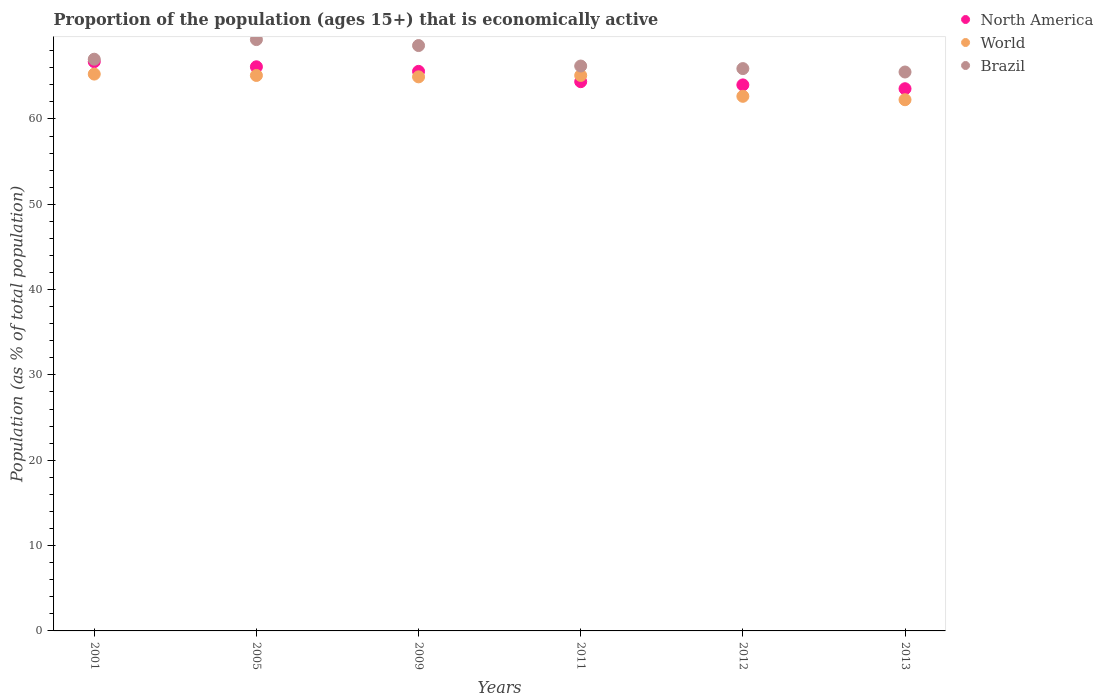How many different coloured dotlines are there?
Your response must be concise. 3. Is the number of dotlines equal to the number of legend labels?
Make the answer very short. Yes. What is the proportion of the population that is economically active in World in 2011?
Offer a very short reply. 65.1. Across all years, what is the maximum proportion of the population that is economically active in North America?
Provide a short and direct response. 66.71. Across all years, what is the minimum proportion of the population that is economically active in North America?
Offer a terse response. 63.54. In which year was the proportion of the population that is economically active in North America maximum?
Offer a terse response. 2001. In which year was the proportion of the population that is economically active in North America minimum?
Your answer should be compact. 2013. What is the total proportion of the population that is economically active in Brazil in the graph?
Keep it short and to the point. 402.5. What is the difference between the proportion of the population that is economically active in Brazil in 2009 and that in 2011?
Provide a short and direct response. 2.4. What is the difference between the proportion of the population that is economically active in Brazil in 2001 and the proportion of the population that is economically active in World in 2009?
Provide a short and direct response. 2.07. What is the average proportion of the population that is economically active in Brazil per year?
Ensure brevity in your answer.  67.08. In the year 2005, what is the difference between the proportion of the population that is economically active in North America and proportion of the population that is economically active in World?
Offer a terse response. 1.02. What is the ratio of the proportion of the population that is economically active in North America in 2009 to that in 2012?
Keep it short and to the point. 1.02. Is the difference between the proportion of the population that is economically active in North America in 2005 and 2012 greater than the difference between the proportion of the population that is economically active in World in 2005 and 2012?
Provide a short and direct response. No. What is the difference between the highest and the second highest proportion of the population that is economically active in North America?
Your answer should be compact. 0.6. What is the difference between the highest and the lowest proportion of the population that is economically active in Brazil?
Your response must be concise. 3.8. In how many years, is the proportion of the population that is economically active in Brazil greater than the average proportion of the population that is economically active in Brazil taken over all years?
Your response must be concise. 2. Is the sum of the proportion of the population that is economically active in Brazil in 2005 and 2009 greater than the maximum proportion of the population that is economically active in North America across all years?
Offer a very short reply. Yes. How many years are there in the graph?
Your answer should be compact. 6. Are the values on the major ticks of Y-axis written in scientific E-notation?
Provide a short and direct response. No. Does the graph contain any zero values?
Give a very brief answer. No. Where does the legend appear in the graph?
Offer a terse response. Top right. How many legend labels are there?
Your answer should be compact. 3. What is the title of the graph?
Your answer should be very brief. Proportion of the population (ages 15+) that is economically active. Does "High income: nonOECD" appear as one of the legend labels in the graph?
Your response must be concise. No. What is the label or title of the Y-axis?
Provide a succinct answer. Population (as % of total population). What is the Population (as % of total population) in North America in 2001?
Ensure brevity in your answer.  66.71. What is the Population (as % of total population) of World in 2001?
Make the answer very short. 65.26. What is the Population (as % of total population) in Brazil in 2001?
Your answer should be compact. 67. What is the Population (as % of total population) in North America in 2005?
Offer a very short reply. 66.11. What is the Population (as % of total population) of World in 2005?
Give a very brief answer. 65.1. What is the Population (as % of total population) in Brazil in 2005?
Make the answer very short. 69.3. What is the Population (as % of total population) of North America in 2009?
Your response must be concise. 65.57. What is the Population (as % of total population) of World in 2009?
Ensure brevity in your answer.  64.93. What is the Population (as % of total population) in Brazil in 2009?
Offer a terse response. 68.6. What is the Population (as % of total population) in North America in 2011?
Provide a short and direct response. 64.37. What is the Population (as % of total population) of World in 2011?
Offer a terse response. 65.1. What is the Population (as % of total population) of Brazil in 2011?
Give a very brief answer. 66.2. What is the Population (as % of total population) in North America in 2012?
Your response must be concise. 63.99. What is the Population (as % of total population) of World in 2012?
Offer a terse response. 62.65. What is the Population (as % of total population) in Brazil in 2012?
Offer a terse response. 65.9. What is the Population (as % of total population) in North America in 2013?
Ensure brevity in your answer.  63.54. What is the Population (as % of total population) of World in 2013?
Give a very brief answer. 62.25. What is the Population (as % of total population) of Brazil in 2013?
Make the answer very short. 65.5. Across all years, what is the maximum Population (as % of total population) of North America?
Your answer should be compact. 66.71. Across all years, what is the maximum Population (as % of total population) of World?
Ensure brevity in your answer.  65.26. Across all years, what is the maximum Population (as % of total population) of Brazil?
Provide a succinct answer. 69.3. Across all years, what is the minimum Population (as % of total population) of North America?
Offer a very short reply. 63.54. Across all years, what is the minimum Population (as % of total population) of World?
Offer a terse response. 62.25. Across all years, what is the minimum Population (as % of total population) in Brazil?
Offer a terse response. 65.5. What is the total Population (as % of total population) of North America in the graph?
Provide a succinct answer. 390.29. What is the total Population (as % of total population) in World in the graph?
Ensure brevity in your answer.  385.28. What is the total Population (as % of total population) in Brazil in the graph?
Offer a very short reply. 402.5. What is the difference between the Population (as % of total population) of North America in 2001 and that in 2005?
Your answer should be very brief. 0.6. What is the difference between the Population (as % of total population) in World in 2001 and that in 2005?
Your answer should be very brief. 0.16. What is the difference between the Population (as % of total population) of North America in 2001 and that in 2009?
Your response must be concise. 1.14. What is the difference between the Population (as % of total population) of World in 2001 and that in 2009?
Keep it short and to the point. 0.32. What is the difference between the Population (as % of total population) in Brazil in 2001 and that in 2009?
Your answer should be very brief. -1.6. What is the difference between the Population (as % of total population) in North America in 2001 and that in 2011?
Offer a very short reply. 2.34. What is the difference between the Population (as % of total population) in World in 2001 and that in 2011?
Give a very brief answer. 0.16. What is the difference between the Population (as % of total population) in Brazil in 2001 and that in 2011?
Make the answer very short. 0.8. What is the difference between the Population (as % of total population) in North America in 2001 and that in 2012?
Provide a short and direct response. 2.72. What is the difference between the Population (as % of total population) of World in 2001 and that in 2012?
Provide a succinct answer. 2.6. What is the difference between the Population (as % of total population) in Brazil in 2001 and that in 2012?
Make the answer very short. 1.1. What is the difference between the Population (as % of total population) of North America in 2001 and that in 2013?
Keep it short and to the point. 3.17. What is the difference between the Population (as % of total population) of World in 2001 and that in 2013?
Give a very brief answer. 3. What is the difference between the Population (as % of total population) in North America in 2005 and that in 2009?
Ensure brevity in your answer.  0.54. What is the difference between the Population (as % of total population) of World in 2005 and that in 2009?
Make the answer very short. 0.16. What is the difference between the Population (as % of total population) in Brazil in 2005 and that in 2009?
Your response must be concise. 0.7. What is the difference between the Population (as % of total population) of North America in 2005 and that in 2011?
Your answer should be very brief. 1.74. What is the difference between the Population (as % of total population) of World in 2005 and that in 2011?
Your answer should be very brief. -0. What is the difference between the Population (as % of total population) in North America in 2005 and that in 2012?
Offer a terse response. 2.12. What is the difference between the Population (as % of total population) in World in 2005 and that in 2012?
Give a very brief answer. 2.44. What is the difference between the Population (as % of total population) of Brazil in 2005 and that in 2012?
Provide a succinct answer. 3.4. What is the difference between the Population (as % of total population) of North America in 2005 and that in 2013?
Your response must be concise. 2.57. What is the difference between the Population (as % of total population) in World in 2005 and that in 2013?
Your answer should be compact. 2.84. What is the difference between the Population (as % of total population) in North America in 2009 and that in 2011?
Provide a short and direct response. 1.21. What is the difference between the Population (as % of total population) of World in 2009 and that in 2011?
Your answer should be compact. -0.16. What is the difference between the Population (as % of total population) in North America in 2009 and that in 2012?
Ensure brevity in your answer.  1.59. What is the difference between the Population (as % of total population) of World in 2009 and that in 2012?
Offer a terse response. 2.28. What is the difference between the Population (as % of total population) in North America in 2009 and that in 2013?
Make the answer very short. 2.03. What is the difference between the Population (as % of total population) of World in 2009 and that in 2013?
Your response must be concise. 2.68. What is the difference between the Population (as % of total population) of Brazil in 2009 and that in 2013?
Make the answer very short. 3.1. What is the difference between the Population (as % of total population) in North America in 2011 and that in 2012?
Offer a very short reply. 0.38. What is the difference between the Population (as % of total population) in World in 2011 and that in 2012?
Give a very brief answer. 2.44. What is the difference between the Population (as % of total population) of Brazil in 2011 and that in 2012?
Provide a succinct answer. 0.3. What is the difference between the Population (as % of total population) of North America in 2011 and that in 2013?
Your answer should be compact. 0.83. What is the difference between the Population (as % of total population) in World in 2011 and that in 2013?
Give a very brief answer. 2.85. What is the difference between the Population (as % of total population) in North America in 2012 and that in 2013?
Provide a succinct answer. 0.45. What is the difference between the Population (as % of total population) in World in 2012 and that in 2013?
Ensure brevity in your answer.  0.4. What is the difference between the Population (as % of total population) of Brazil in 2012 and that in 2013?
Your response must be concise. 0.4. What is the difference between the Population (as % of total population) in North America in 2001 and the Population (as % of total population) in World in 2005?
Offer a very short reply. 1.61. What is the difference between the Population (as % of total population) in North America in 2001 and the Population (as % of total population) in Brazil in 2005?
Offer a very short reply. -2.59. What is the difference between the Population (as % of total population) of World in 2001 and the Population (as % of total population) of Brazil in 2005?
Provide a succinct answer. -4.04. What is the difference between the Population (as % of total population) of North America in 2001 and the Population (as % of total population) of World in 2009?
Your answer should be very brief. 1.78. What is the difference between the Population (as % of total population) in North America in 2001 and the Population (as % of total population) in Brazil in 2009?
Ensure brevity in your answer.  -1.89. What is the difference between the Population (as % of total population) of World in 2001 and the Population (as % of total population) of Brazil in 2009?
Keep it short and to the point. -3.34. What is the difference between the Population (as % of total population) of North America in 2001 and the Population (as % of total population) of World in 2011?
Your answer should be compact. 1.61. What is the difference between the Population (as % of total population) of North America in 2001 and the Population (as % of total population) of Brazil in 2011?
Make the answer very short. 0.51. What is the difference between the Population (as % of total population) of World in 2001 and the Population (as % of total population) of Brazil in 2011?
Your answer should be compact. -0.94. What is the difference between the Population (as % of total population) in North America in 2001 and the Population (as % of total population) in World in 2012?
Your answer should be compact. 4.06. What is the difference between the Population (as % of total population) of North America in 2001 and the Population (as % of total population) of Brazil in 2012?
Your response must be concise. 0.81. What is the difference between the Population (as % of total population) in World in 2001 and the Population (as % of total population) in Brazil in 2012?
Offer a terse response. -0.64. What is the difference between the Population (as % of total population) in North America in 2001 and the Population (as % of total population) in World in 2013?
Make the answer very short. 4.46. What is the difference between the Population (as % of total population) in North America in 2001 and the Population (as % of total population) in Brazil in 2013?
Offer a very short reply. 1.21. What is the difference between the Population (as % of total population) in World in 2001 and the Population (as % of total population) in Brazil in 2013?
Your response must be concise. -0.24. What is the difference between the Population (as % of total population) in North America in 2005 and the Population (as % of total population) in World in 2009?
Your answer should be very brief. 1.18. What is the difference between the Population (as % of total population) of North America in 2005 and the Population (as % of total population) of Brazil in 2009?
Your answer should be very brief. -2.49. What is the difference between the Population (as % of total population) in World in 2005 and the Population (as % of total population) in Brazil in 2009?
Keep it short and to the point. -3.5. What is the difference between the Population (as % of total population) of North America in 2005 and the Population (as % of total population) of World in 2011?
Provide a short and direct response. 1.02. What is the difference between the Population (as % of total population) in North America in 2005 and the Population (as % of total population) in Brazil in 2011?
Offer a terse response. -0.09. What is the difference between the Population (as % of total population) of World in 2005 and the Population (as % of total population) of Brazil in 2011?
Provide a succinct answer. -1.1. What is the difference between the Population (as % of total population) in North America in 2005 and the Population (as % of total population) in World in 2012?
Provide a short and direct response. 3.46. What is the difference between the Population (as % of total population) of North America in 2005 and the Population (as % of total population) of Brazil in 2012?
Keep it short and to the point. 0.21. What is the difference between the Population (as % of total population) of World in 2005 and the Population (as % of total population) of Brazil in 2012?
Offer a very short reply. -0.8. What is the difference between the Population (as % of total population) of North America in 2005 and the Population (as % of total population) of World in 2013?
Your answer should be very brief. 3.86. What is the difference between the Population (as % of total population) of North America in 2005 and the Population (as % of total population) of Brazil in 2013?
Give a very brief answer. 0.61. What is the difference between the Population (as % of total population) in World in 2005 and the Population (as % of total population) in Brazil in 2013?
Your answer should be compact. -0.4. What is the difference between the Population (as % of total population) of North America in 2009 and the Population (as % of total population) of World in 2011?
Your answer should be very brief. 0.48. What is the difference between the Population (as % of total population) of North America in 2009 and the Population (as % of total population) of Brazil in 2011?
Keep it short and to the point. -0.63. What is the difference between the Population (as % of total population) in World in 2009 and the Population (as % of total population) in Brazil in 2011?
Keep it short and to the point. -1.27. What is the difference between the Population (as % of total population) of North America in 2009 and the Population (as % of total population) of World in 2012?
Keep it short and to the point. 2.92. What is the difference between the Population (as % of total population) of North America in 2009 and the Population (as % of total population) of Brazil in 2012?
Offer a very short reply. -0.33. What is the difference between the Population (as % of total population) of World in 2009 and the Population (as % of total population) of Brazil in 2012?
Offer a terse response. -0.97. What is the difference between the Population (as % of total population) in North America in 2009 and the Population (as % of total population) in World in 2013?
Provide a short and direct response. 3.32. What is the difference between the Population (as % of total population) of North America in 2009 and the Population (as % of total population) of Brazil in 2013?
Ensure brevity in your answer.  0.07. What is the difference between the Population (as % of total population) of World in 2009 and the Population (as % of total population) of Brazil in 2013?
Keep it short and to the point. -0.57. What is the difference between the Population (as % of total population) in North America in 2011 and the Population (as % of total population) in World in 2012?
Your answer should be very brief. 1.72. What is the difference between the Population (as % of total population) of North America in 2011 and the Population (as % of total population) of Brazil in 2012?
Provide a succinct answer. -1.53. What is the difference between the Population (as % of total population) of World in 2011 and the Population (as % of total population) of Brazil in 2012?
Provide a succinct answer. -0.8. What is the difference between the Population (as % of total population) in North America in 2011 and the Population (as % of total population) in World in 2013?
Provide a short and direct response. 2.12. What is the difference between the Population (as % of total population) of North America in 2011 and the Population (as % of total population) of Brazil in 2013?
Your response must be concise. -1.13. What is the difference between the Population (as % of total population) in World in 2011 and the Population (as % of total population) in Brazil in 2013?
Your answer should be compact. -0.4. What is the difference between the Population (as % of total population) of North America in 2012 and the Population (as % of total population) of World in 2013?
Provide a short and direct response. 1.74. What is the difference between the Population (as % of total population) in North America in 2012 and the Population (as % of total population) in Brazil in 2013?
Your response must be concise. -1.51. What is the difference between the Population (as % of total population) in World in 2012 and the Population (as % of total population) in Brazil in 2013?
Your response must be concise. -2.85. What is the average Population (as % of total population) of North America per year?
Provide a short and direct response. 65.05. What is the average Population (as % of total population) in World per year?
Provide a succinct answer. 64.21. What is the average Population (as % of total population) of Brazil per year?
Offer a terse response. 67.08. In the year 2001, what is the difference between the Population (as % of total population) of North America and Population (as % of total population) of World?
Make the answer very short. 1.45. In the year 2001, what is the difference between the Population (as % of total population) of North America and Population (as % of total population) of Brazil?
Your answer should be compact. -0.29. In the year 2001, what is the difference between the Population (as % of total population) in World and Population (as % of total population) in Brazil?
Provide a succinct answer. -1.74. In the year 2005, what is the difference between the Population (as % of total population) of North America and Population (as % of total population) of World?
Your response must be concise. 1.02. In the year 2005, what is the difference between the Population (as % of total population) in North America and Population (as % of total population) in Brazil?
Give a very brief answer. -3.19. In the year 2005, what is the difference between the Population (as % of total population) in World and Population (as % of total population) in Brazil?
Keep it short and to the point. -4.2. In the year 2009, what is the difference between the Population (as % of total population) of North America and Population (as % of total population) of World?
Offer a terse response. 0.64. In the year 2009, what is the difference between the Population (as % of total population) in North America and Population (as % of total population) in Brazil?
Your answer should be compact. -3.03. In the year 2009, what is the difference between the Population (as % of total population) in World and Population (as % of total population) in Brazil?
Offer a terse response. -3.67. In the year 2011, what is the difference between the Population (as % of total population) in North America and Population (as % of total population) in World?
Your response must be concise. -0.73. In the year 2011, what is the difference between the Population (as % of total population) in North America and Population (as % of total population) in Brazil?
Provide a short and direct response. -1.83. In the year 2011, what is the difference between the Population (as % of total population) of World and Population (as % of total population) of Brazil?
Provide a short and direct response. -1.1. In the year 2012, what is the difference between the Population (as % of total population) of North America and Population (as % of total population) of World?
Make the answer very short. 1.34. In the year 2012, what is the difference between the Population (as % of total population) in North America and Population (as % of total population) in Brazil?
Your answer should be compact. -1.91. In the year 2012, what is the difference between the Population (as % of total population) in World and Population (as % of total population) in Brazil?
Make the answer very short. -3.25. In the year 2013, what is the difference between the Population (as % of total population) in North America and Population (as % of total population) in World?
Offer a terse response. 1.29. In the year 2013, what is the difference between the Population (as % of total population) in North America and Population (as % of total population) in Brazil?
Make the answer very short. -1.96. In the year 2013, what is the difference between the Population (as % of total population) in World and Population (as % of total population) in Brazil?
Keep it short and to the point. -3.25. What is the ratio of the Population (as % of total population) of Brazil in 2001 to that in 2005?
Ensure brevity in your answer.  0.97. What is the ratio of the Population (as % of total population) of North America in 2001 to that in 2009?
Offer a terse response. 1.02. What is the ratio of the Population (as % of total population) in Brazil in 2001 to that in 2009?
Offer a terse response. 0.98. What is the ratio of the Population (as % of total population) of North America in 2001 to that in 2011?
Your answer should be compact. 1.04. What is the ratio of the Population (as % of total population) in Brazil in 2001 to that in 2011?
Ensure brevity in your answer.  1.01. What is the ratio of the Population (as % of total population) of North America in 2001 to that in 2012?
Keep it short and to the point. 1.04. What is the ratio of the Population (as % of total population) in World in 2001 to that in 2012?
Your answer should be very brief. 1.04. What is the ratio of the Population (as % of total population) of Brazil in 2001 to that in 2012?
Your answer should be compact. 1.02. What is the ratio of the Population (as % of total population) in North America in 2001 to that in 2013?
Provide a short and direct response. 1.05. What is the ratio of the Population (as % of total population) in World in 2001 to that in 2013?
Keep it short and to the point. 1.05. What is the ratio of the Population (as % of total population) of Brazil in 2001 to that in 2013?
Your response must be concise. 1.02. What is the ratio of the Population (as % of total population) in North America in 2005 to that in 2009?
Your answer should be compact. 1.01. What is the ratio of the Population (as % of total population) of Brazil in 2005 to that in 2009?
Keep it short and to the point. 1.01. What is the ratio of the Population (as % of total population) of North America in 2005 to that in 2011?
Your answer should be compact. 1.03. What is the ratio of the Population (as % of total population) in Brazil in 2005 to that in 2011?
Offer a very short reply. 1.05. What is the ratio of the Population (as % of total population) of North America in 2005 to that in 2012?
Provide a short and direct response. 1.03. What is the ratio of the Population (as % of total population) in World in 2005 to that in 2012?
Provide a succinct answer. 1.04. What is the ratio of the Population (as % of total population) in Brazil in 2005 to that in 2012?
Offer a very short reply. 1.05. What is the ratio of the Population (as % of total population) of North America in 2005 to that in 2013?
Provide a short and direct response. 1.04. What is the ratio of the Population (as % of total population) in World in 2005 to that in 2013?
Provide a short and direct response. 1.05. What is the ratio of the Population (as % of total population) of Brazil in 2005 to that in 2013?
Ensure brevity in your answer.  1.06. What is the ratio of the Population (as % of total population) in North America in 2009 to that in 2011?
Give a very brief answer. 1.02. What is the ratio of the Population (as % of total population) in World in 2009 to that in 2011?
Provide a succinct answer. 1. What is the ratio of the Population (as % of total population) of Brazil in 2009 to that in 2011?
Provide a short and direct response. 1.04. What is the ratio of the Population (as % of total population) of North America in 2009 to that in 2012?
Offer a terse response. 1.02. What is the ratio of the Population (as % of total population) of World in 2009 to that in 2012?
Give a very brief answer. 1.04. What is the ratio of the Population (as % of total population) of Brazil in 2009 to that in 2012?
Make the answer very short. 1.04. What is the ratio of the Population (as % of total population) of North America in 2009 to that in 2013?
Offer a terse response. 1.03. What is the ratio of the Population (as % of total population) in World in 2009 to that in 2013?
Your response must be concise. 1.04. What is the ratio of the Population (as % of total population) in Brazil in 2009 to that in 2013?
Provide a short and direct response. 1.05. What is the ratio of the Population (as % of total population) of North America in 2011 to that in 2012?
Give a very brief answer. 1.01. What is the ratio of the Population (as % of total population) in World in 2011 to that in 2012?
Ensure brevity in your answer.  1.04. What is the ratio of the Population (as % of total population) of World in 2011 to that in 2013?
Your answer should be very brief. 1.05. What is the ratio of the Population (as % of total population) in Brazil in 2011 to that in 2013?
Ensure brevity in your answer.  1.01. What is the ratio of the Population (as % of total population) in North America in 2012 to that in 2013?
Ensure brevity in your answer.  1.01. What is the ratio of the Population (as % of total population) in World in 2012 to that in 2013?
Ensure brevity in your answer.  1.01. What is the difference between the highest and the second highest Population (as % of total population) in North America?
Provide a succinct answer. 0.6. What is the difference between the highest and the second highest Population (as % of total population) in World?
Offer a terse response. 0.16. What is the difference between the highest and the second highest Population (as % of total population) of Brazil?
Make the answer very short. 0.7. What is the difference between the highest and the lowest Population (as % of total population) of North America?
Make the answer very short. 3.17. What is the difference between the highest and the lowest Population (as % of total population) of World?
Offer a very short reply. 3. 